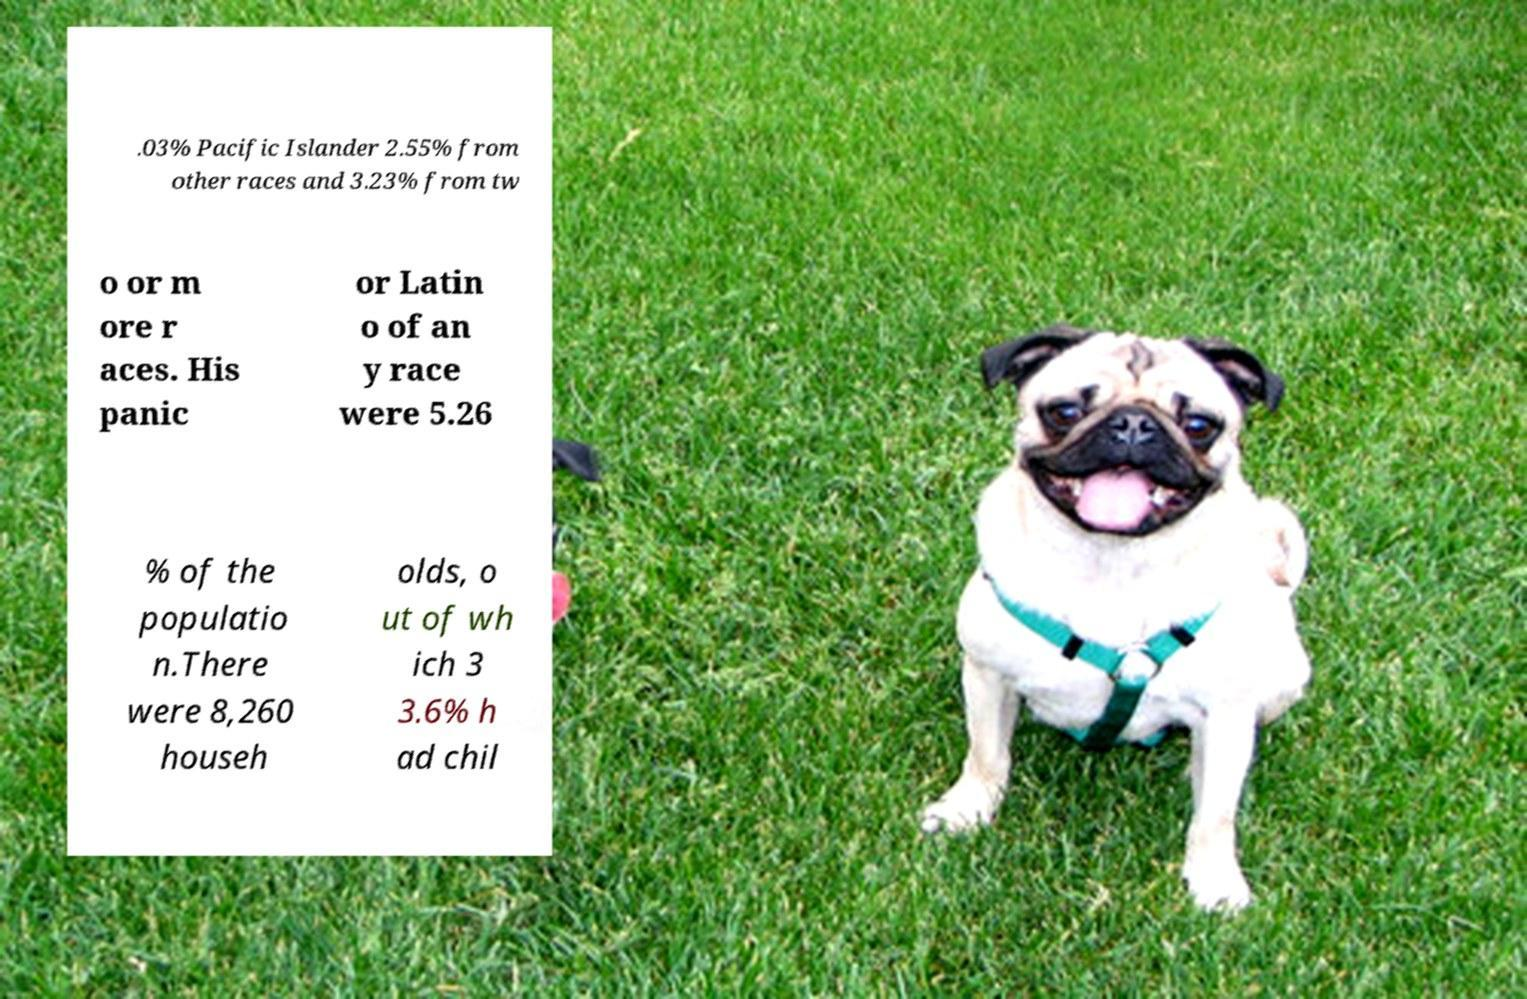Please identify and transcribe the text found in this image. .03% Pacific Islander 2.55% from other races and 3.23% from tw o or m ore r aces. His panic or Latin o of an y race were 5.26 % of the populatio n.There were 8,260 househ olds, o ut of wh ich 3 3.6% h ad chil 